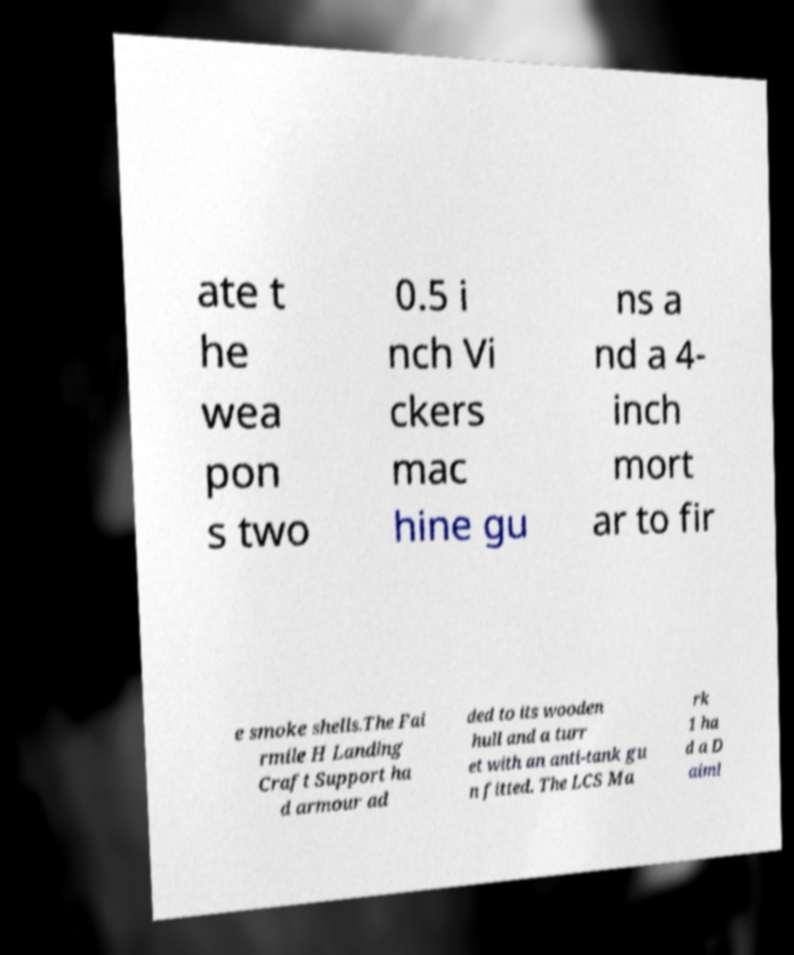Can you read and provide the text displayed in the image?This photo seems to have some interesting text. Can you extract and type it out for me? ate t he wea pon s two 0.5 i nch Vi ckers mac hine gu ns a nd a 4- inch mort ar to fir e smoke shells.The Fai rmile H Landing Craft Support ha d armour ad ded to its wooden hull and a turr et with an anti-tank gu n fitted. The LCS Ma rk 1 ha d a D aiml 